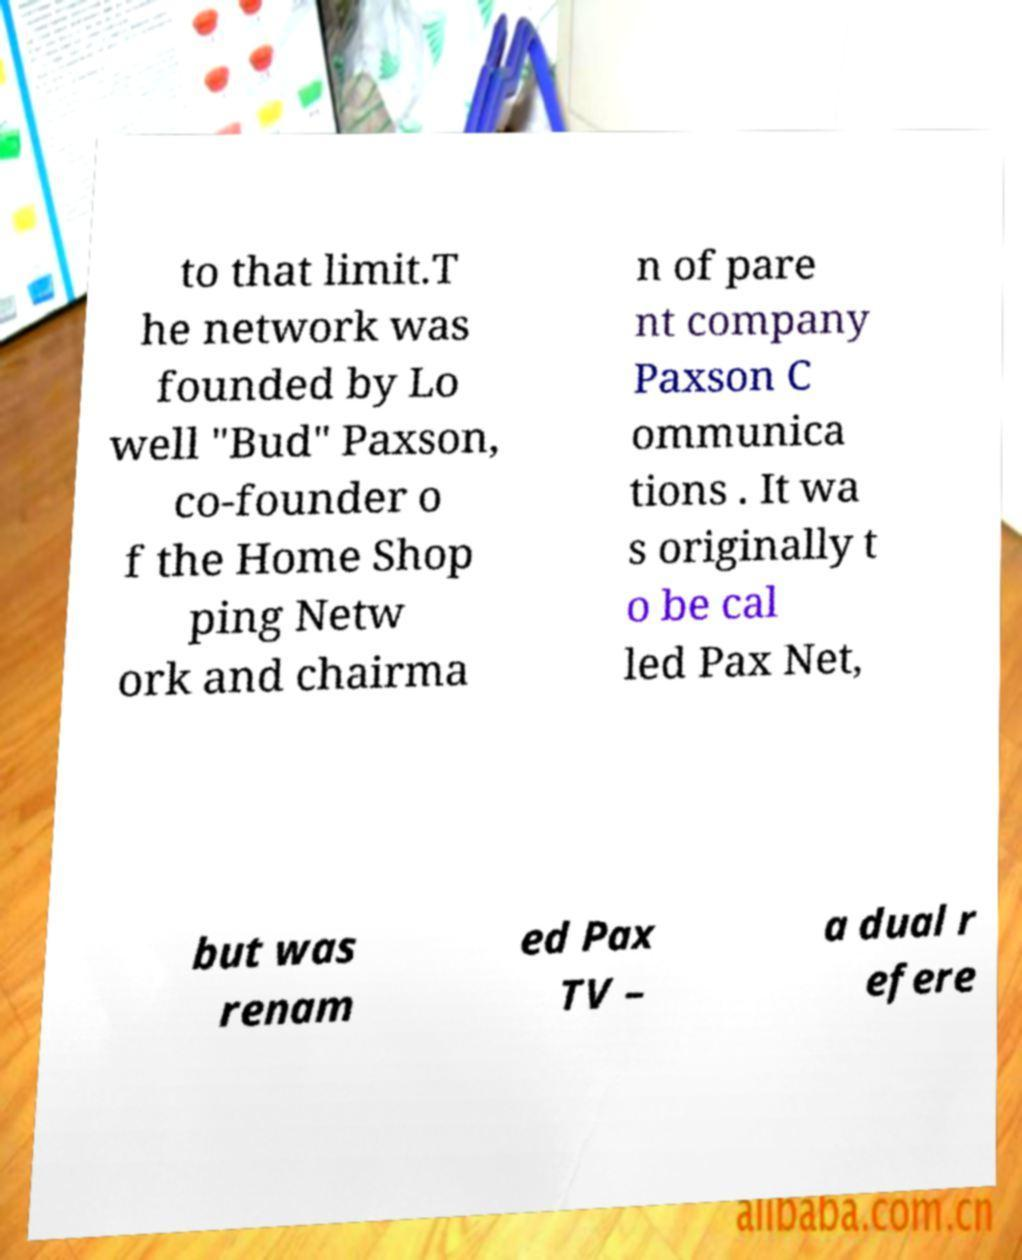What messages or text are displayed in this image? I need them in a readable, typed format. to that limit.T he network was founded by Lo well "Bud" Paxson, co-founder o f the Home Shop ping Netw ork and chairma n of pare nt company Paxson C ommunica tions . It wa s originally t o be cal led Pax Net, but was renam ed Pax TV – a dual r efere 